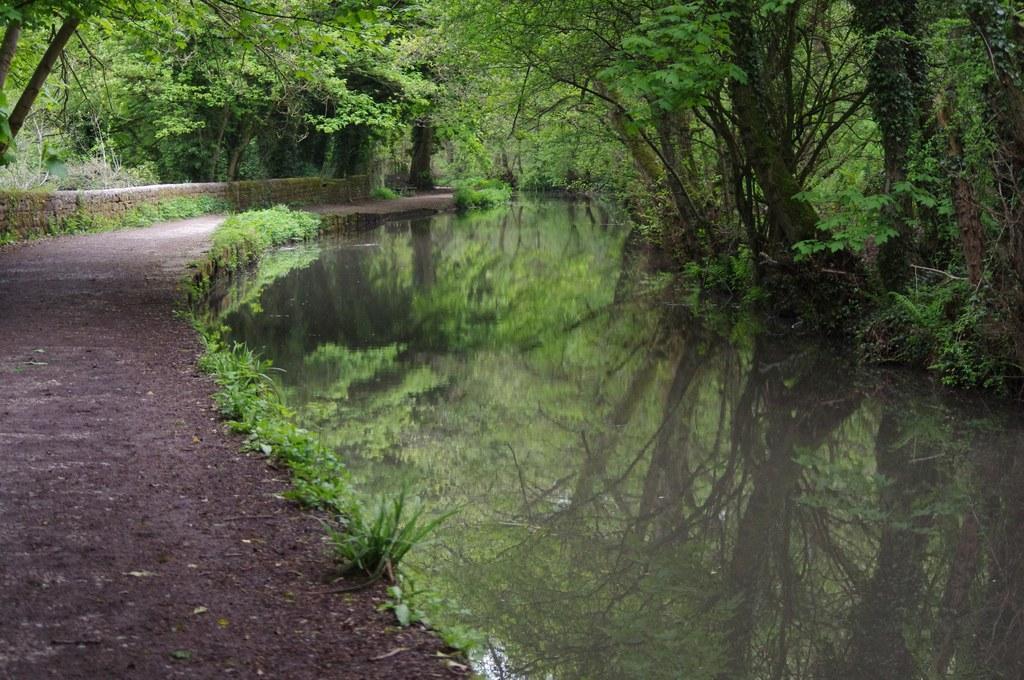Describe this image in one or two sentences. This picture is clicked outside. On the right there is a water body and we can see the trees and plants. On the left there is a path. In the background we can see the trees. 